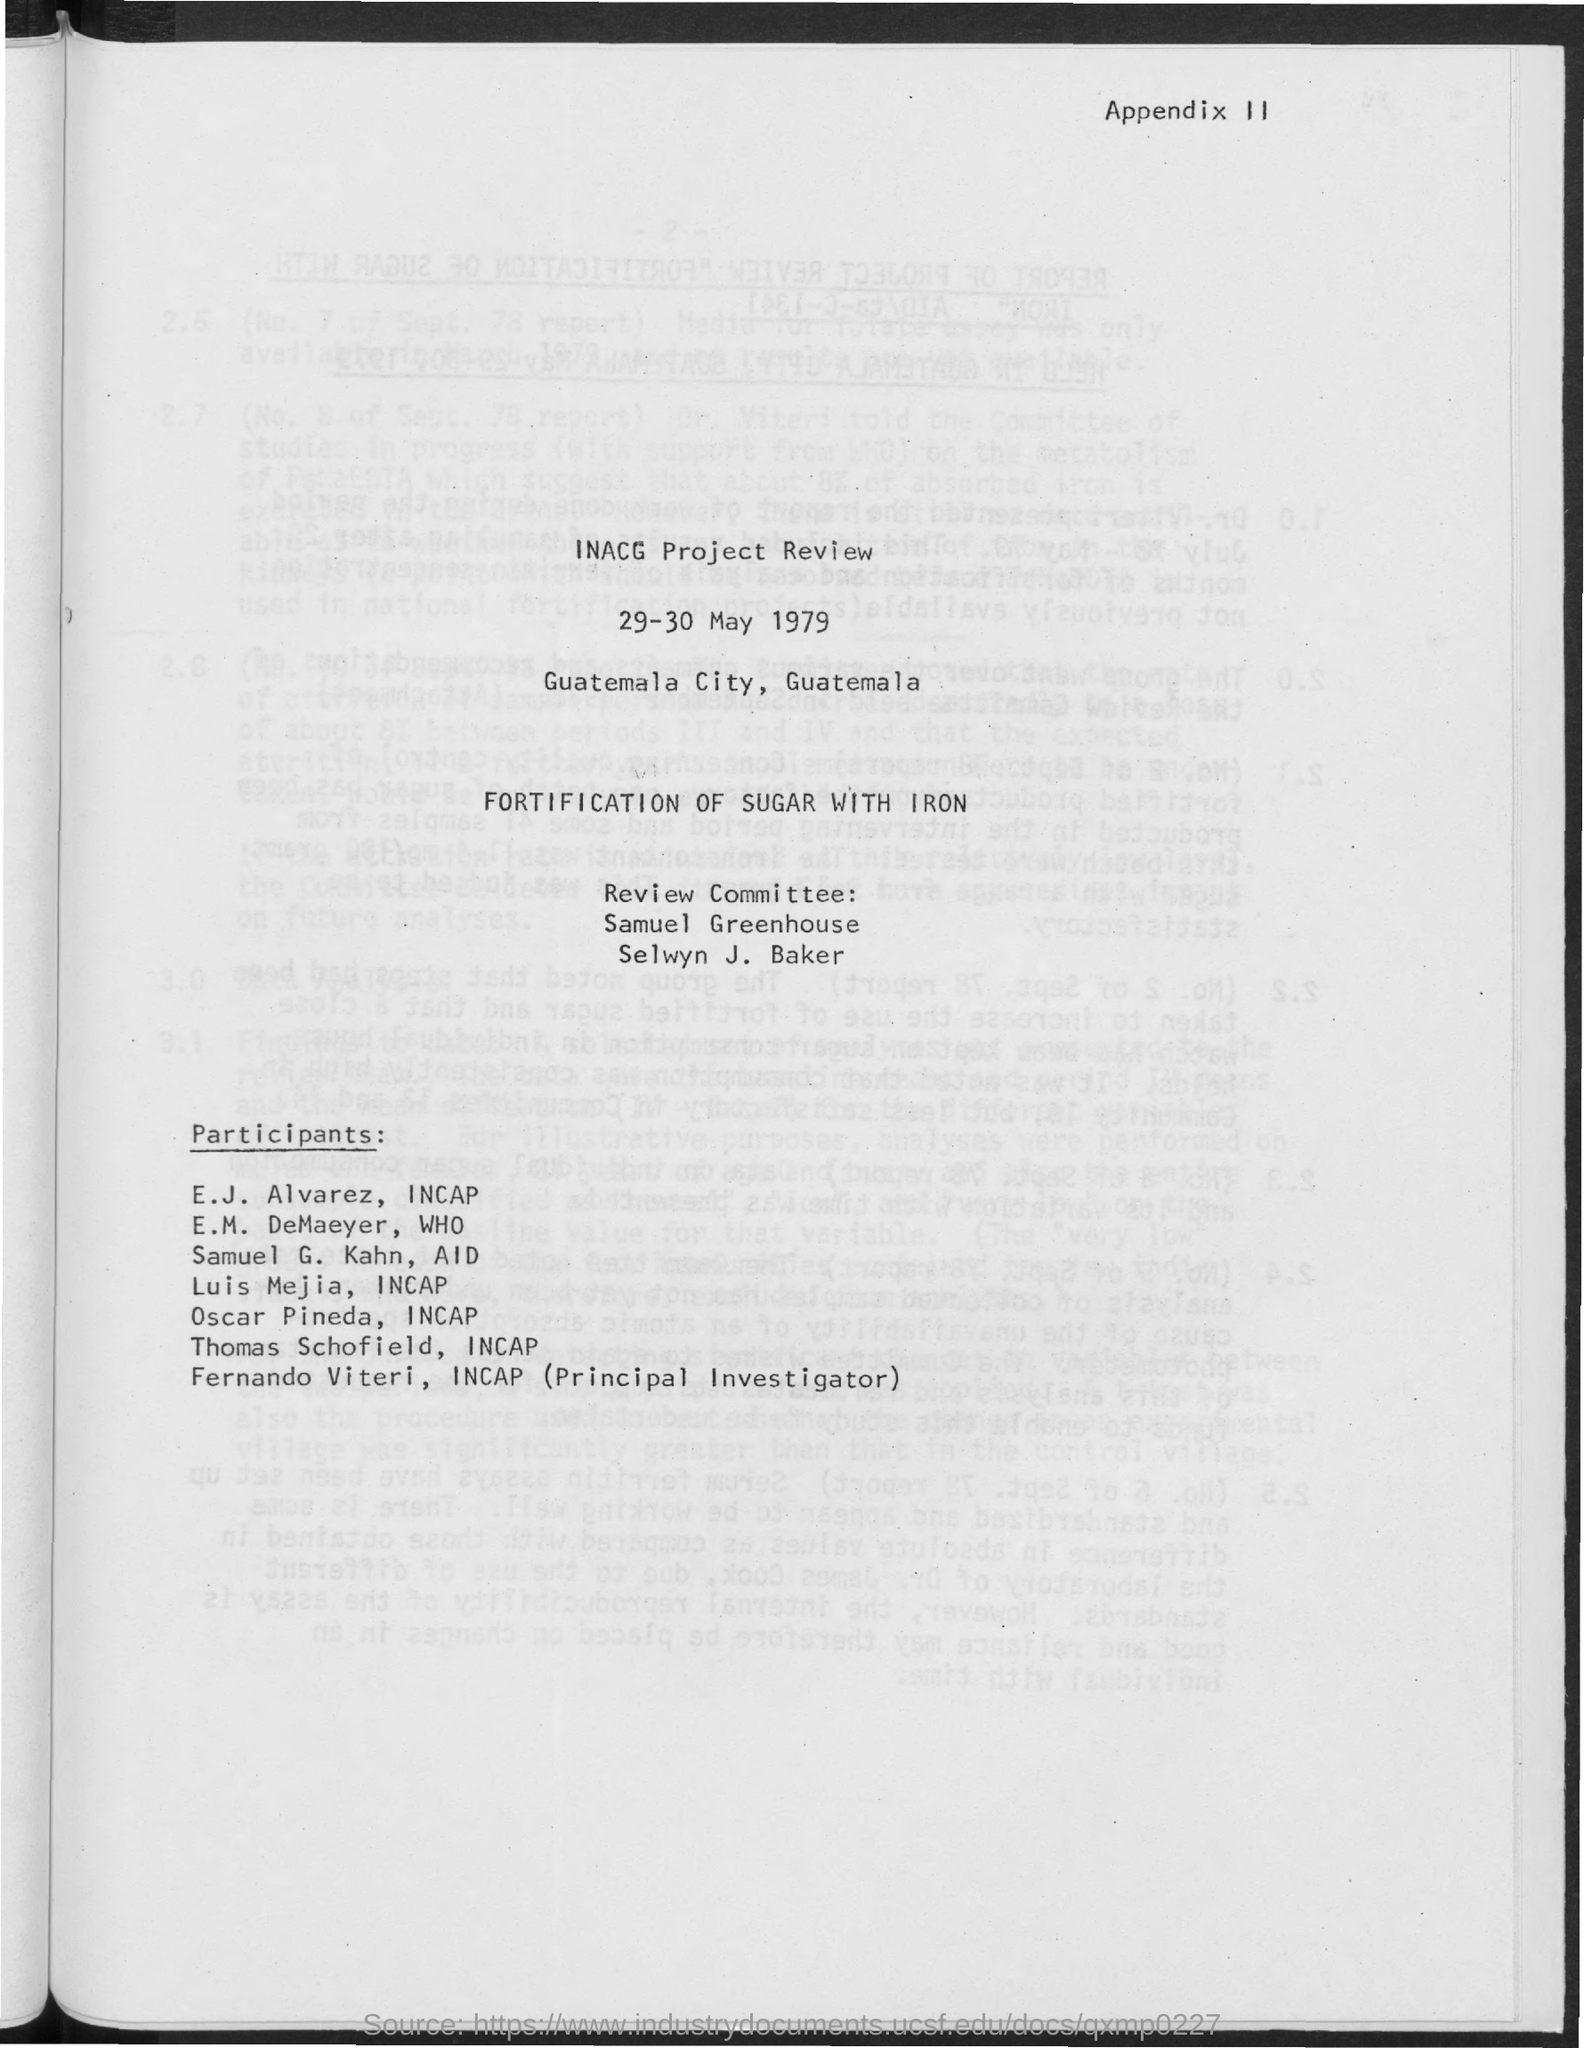Who is the Principal Investigator?
Give a very brief answer. Fernando viteri. What is the first title in the document?
Your answer should be very brief. Inacg project review. What is the date mentioned in the document?
Your answer should be compact. 29-30 may 1979. E.M. DeMaeyer is a member of which organization?
Your answer should be very brief. Who. Samuel G. Kahn is a member of which organization?
Provide a short and direct response. Aid. Luis Mejia is a member of which organization?
Your answer should be compact. Incap. 